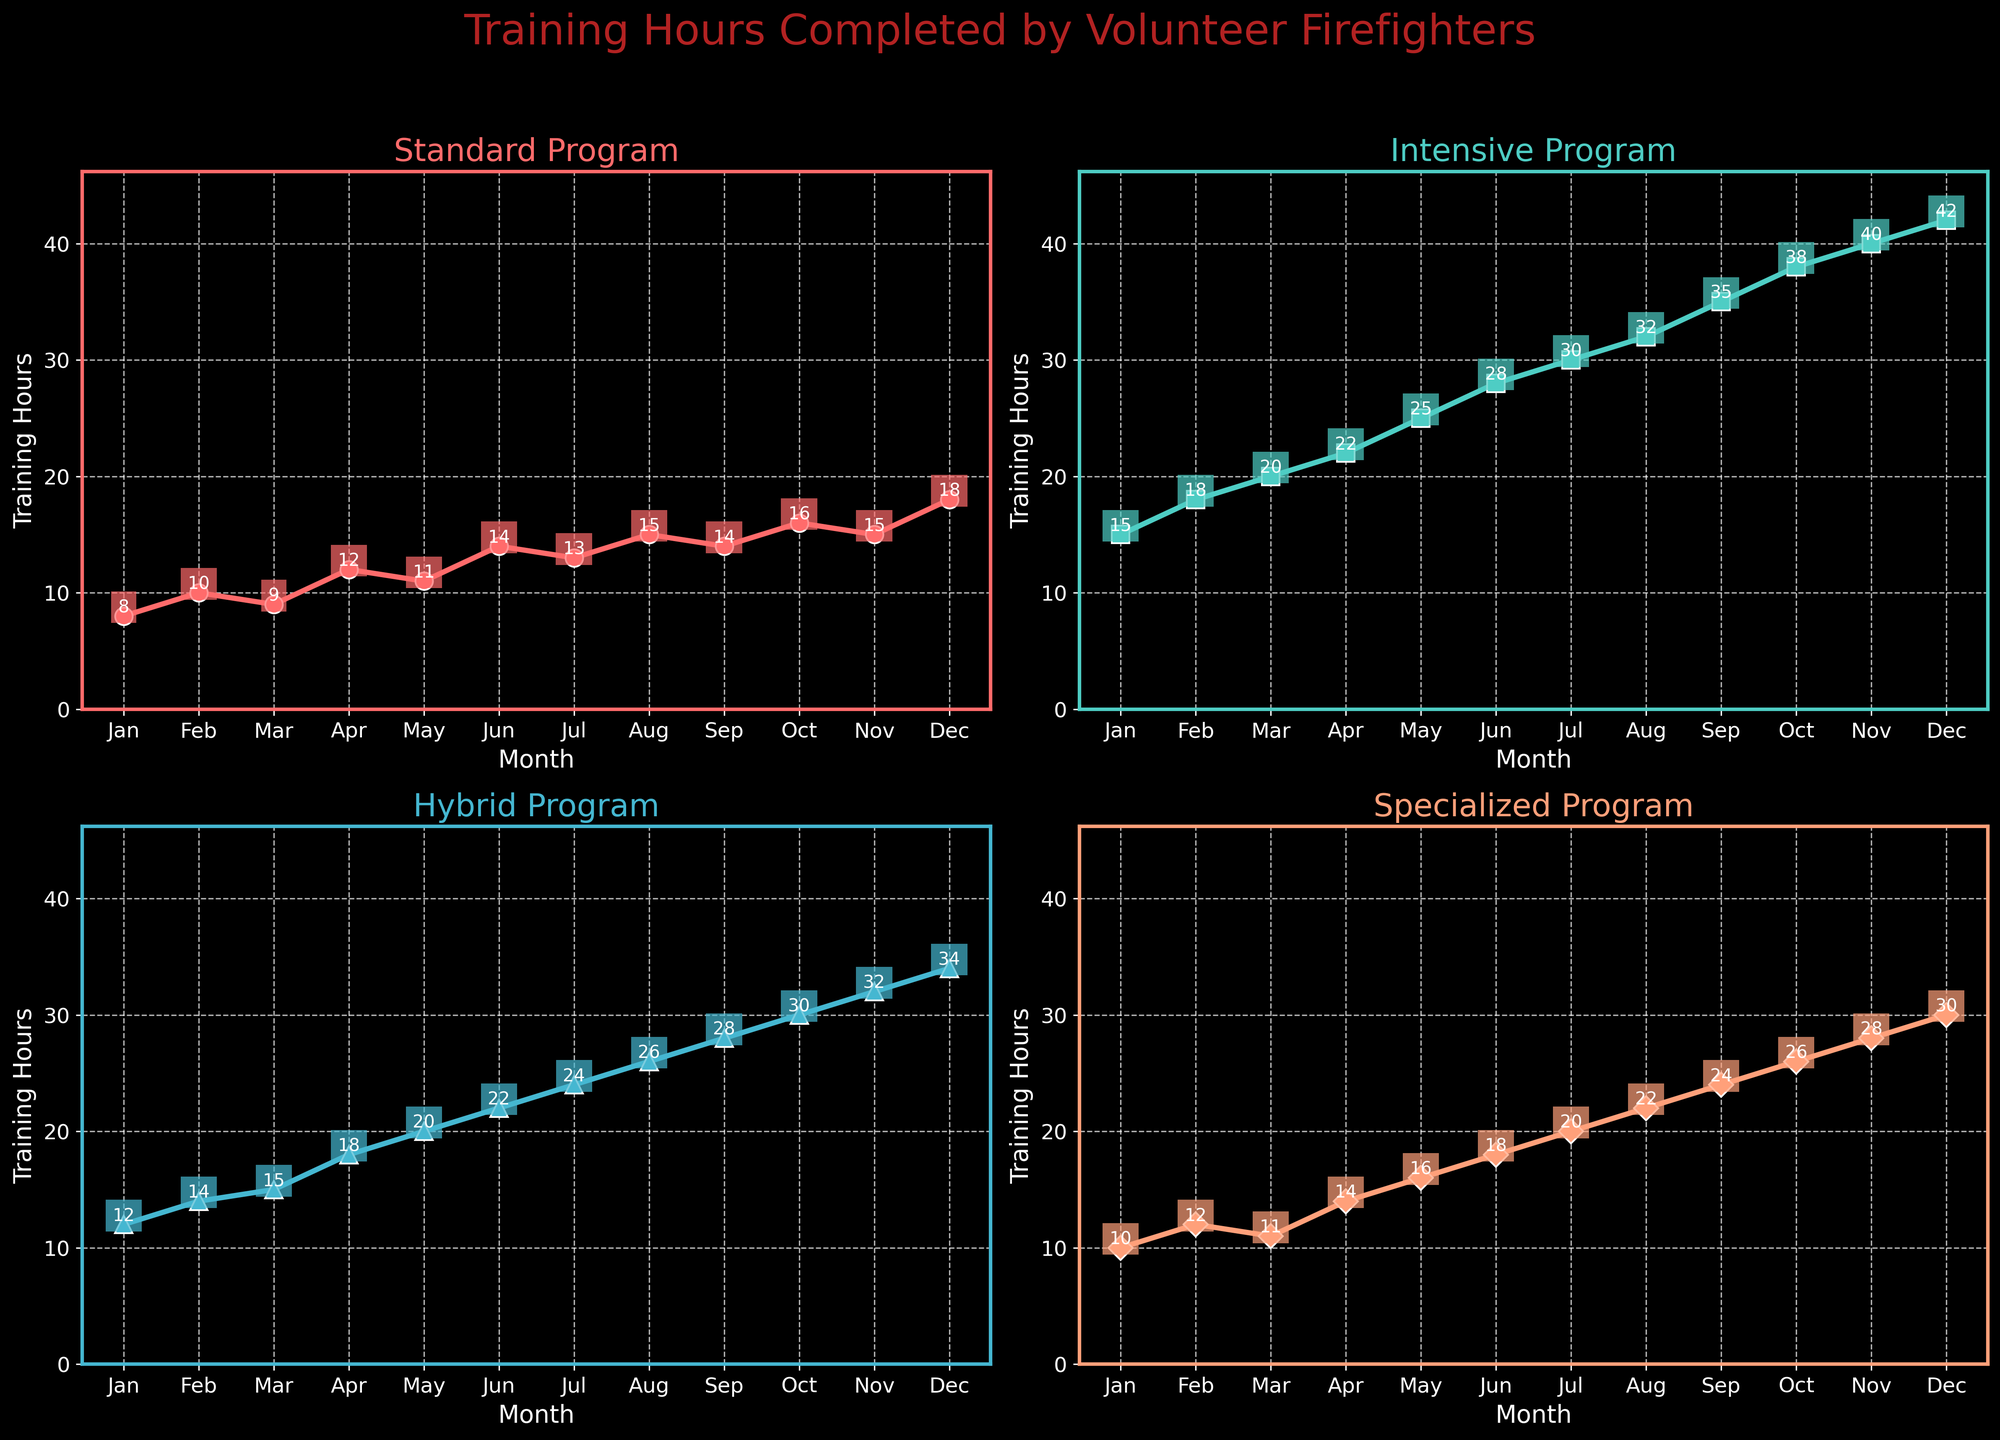What's the training program with the highest number of training hours in December? We examine the four subplots. In December, the training hours are: Standard Program (18), Intensive Program (42), Hybrid Program (34), and Specialized Program (30). The Intensive Program has the highest value.
Answer: Intensive Program Which month has the lowest number of training hours for the Standard Program? The training hours for the Standard Program in each month can be observed: Jan (8), Feb (10), Mar (9), Apr (12), May (11), Jun (14), Jul (13), Aug (15), Sep (14), Oct (16), Nov (15), Dec (18). The lowest number is 8 in January.
Answer: January What is the average number of training hours for the Hybrid Program in the first quarter (Jan-Mar)? Sum the training hours for Jan (12), Feb (14), and Mar (15): 12 + 14 + 15 = 41. Divide by 3 to get the average: 41/3 = 13.67.
Answer: 13.67 How many more training hours were completed in the Intensive Program compared to the Specialized Program in August? Intensive Program has 32 hours in August and Specialized Program has 22 hours. The difference is 32 - 22 = 10 hours.
Answer: 10 In which month does the Specialized Program have the same number of training hours as the Hybrid Program? Comparing the training hours month by month: In October, Hybrid Program has 30 hours, and Specialized Program also has 30 hours.
Answer: October What is the total number of training hours for the Standard Program from July to December? Sum the training hours from Jul (13), Aug (15), Sep (14), Oct (16), Nov (15), Dec (18): 13 + 15 + 14 + 16 + 15 + 18 = 91.
Answer: 91 Which program shows the steepest increase in training hours from January to December? Calculating the increase from Jan to Dec: 
- Standard Program: 18 - 8 = 10 
- Intensive Program: 42 - 15 = 27 
- Hybrid Program: 34 - 12 = 22 
- Specialized Program: 30 - 10 = 20 
The Intensive Program has the steepest increase.
Answer: Intensive Program How many times did the Specialized Program have fewer training hours than the Standard Program? Comparing the training hours between Standard and Specialized Programs month by month: 
- Jan: 8 < 10 
- Feb: 10 < 12 
- Mar: 9 < 11 
- Apr: 12 < 14 
- May: 11 < 16 
- Jun: 14 < 18 
- Jul: 13 < 20 
- Aug: 15 > 22 
- Sep: 14 > 24 
- Oct: 16 > 26 
- Nov: 15 > 28 
- Dec: 18 > 30
It happens 7 times.
Answer: 7 In which month does the Intensive Program see its highest increase from the previous month? Calculating monthly differences for Intensive Program:
- Feb - Jan: 18 - 15 = 3 
- Mar - Feb: 20 - 18 = 2 
- Apr - Mar: 22 - 20 = 2 
- May - Apr: 25 - 22 = 3 
- Jun - May: 28 - 25 = 3 
- Jul - Jun: 30 - 28 = 2 
- Aug - Jul: 32 - 30 = 2 
- Sep - Aug: 35 - 32 = 3 
- Oct - Sep: 38 - 35 = 3 
- Nov - Oct: 40 - 38 = 2 
- Dec - Nov: 42 - 40 = 2
The months with the highest increase are Feb, May, Jun, and Sep, with an increase of 3 hours each.
Answer: February, May, June, September 